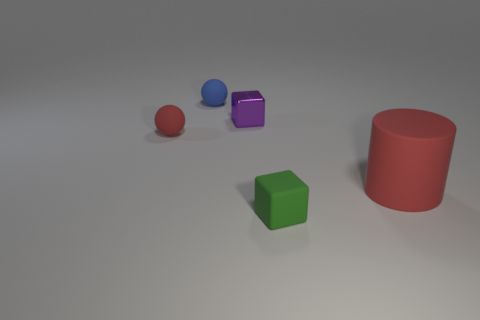Add 5 big blue metallic objects. How many objects exist? 10 Subtract 1 spheres. How many spheres are left? 1 Subtract all blue balls. How many balls are left? 1 Subtract all cylinders. How many objects are left? 4 Add 4 tiny blue spheres. How many tiny blue spheres are left? 5 Add 5 tiny matte cubes. How many tiny matte cubes exist? 6 Subtract 0 red cubes. How many objects are left? 5 Subtract all green balls. Subtract all cyan cubes. How many balls are left? 2 Subtract all yellow balls. Subtract all small blue matte objects. How many objects are left? 4 